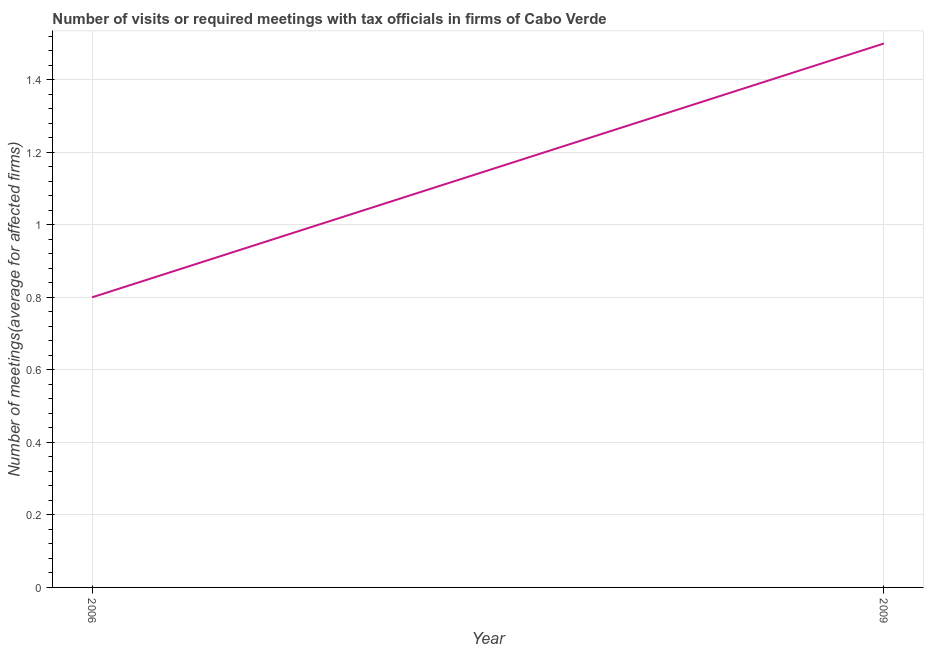Across all years, what is the maximum number of required meetings with tax officials?
Ensure brevity in your answer.  1.5. Across all years, what is the minimum number of required meetings with tax officials?
Keep it short and to the point. 0.8. In which year was the number of required meetings with tax officials minimum?
Give a very brief answer. 2006. What is the sum of the number of required meetings with tax officials?
Provide a succinct answer. 2.3. What is the difference between the number of required meetings with tax officials in 2006 and 2009?
Offer a terse response. -0.7. What is the average number of required meetings with tax officials per year?
Your answer should be compact. 1.15. What is the median number of required meetings with tax officials?
Give a very brief answer. 1.15. What is the ratio of the number of required meetings with tax officials in 2006 to that in 2009?
Give a very brief answer. 0.53. In how many years, is the number of required meetings with tax officials greater than the average number of required meetings with tax officials taken over all years?
Offer a terse response. 1. Does the number of required meetings with tax officials monotonically increase over the years?
Your answer should be very brief. Yes. How many lines are there?
Your response must be concise. 1. What is the difference between two consecutive major ticks on the Y-axis?
Offer a very short reply. 0.2. Are the values on the major ticks of Y-axis written in scientific E-notation?
Make the answer very short. No. Does the graph contain any zero values?
Provide a short and direct response. No. What is the title of the graph?
Make the answer very short. Number of visits or required meetings with tax officials in firms of Cabo Verde. What is the label or title of the X-axis?
Provide a succinct answer. Year. What is the label or title of the Y-axis?
Keep it short and to the point. Number of meetings(average for affected firms). What is the Number of meetings(average for affected firms) in 2009?
Ensure brevity in your answer.  1.5. What is the ratio of the Number of meetings(average for affected firms) in 2006 to that in 2009?
Give a very brief answer. 0.53. 